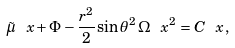<formula> <loc_0><loc_0><loc_500><loc_500>\tilde { \mu } _ { \ } x + \Phi - \frac { r ^ { 2 } } { 2 } \sin \theta ^ { 2 } \, \Omega _ { \ } x ^ { 2 } = C _ { \ } x \, ,</formula> 